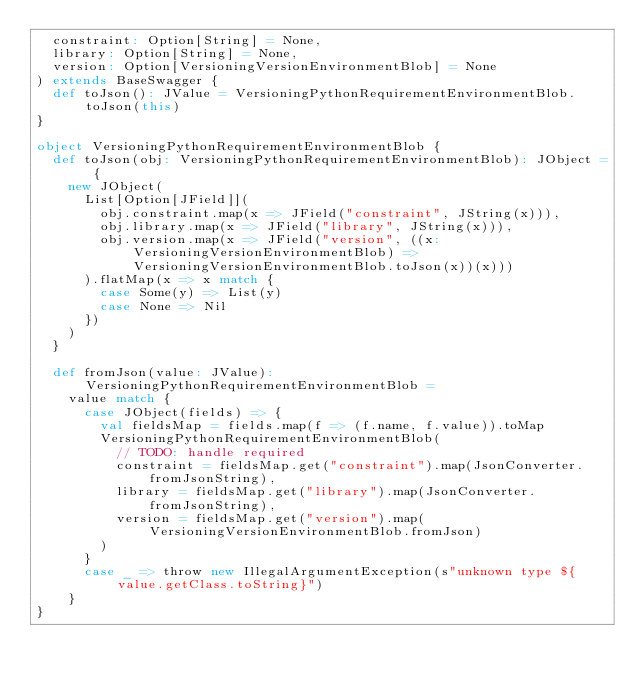<code> <loc_0><loc_0><loc_500><loc_500><_Scala_>  constraint: Option[String] = None,
  library: Option[String] = None,
  version: Option[VersioningVersionEnvironmentBlob] = None
) extends BaseSwagger {
  def toJson(): JValue = VersioningPythonRequirementEnvironmentBlob.toJson(this)
}

object VersioningPythonRequirementEnvironmentBlob {
  def toJson(obj: VersioningPythonRequirementEnvironmentBlob): JObject = {
    new JObject(
      List[Option[JField]](
        obj.constraint.map(x => JField("constraint", JString(x))),
        obj.library.map(x => JField("library", JString(x))),
        obj.version.map(x => JField("version", ((x: VersioningVersionEnvironmentBlob) => VersioningVersionEnvironmentBlob.toJson(x))(x)))
      ).flatMap(x => x match {
        case Some(y) => List(y)
        case None => Nil
      })
    )
  }

  def fromJson(value: JValue): VersioningPythonRequirementEnvironmentBlob =
    value match {
      case JObject(fields) => {
        val fieldsMap = fields.map(f => (f.name, f.value)).toMap
        VersioningPythonRequirementEnvironmentBlob(
          // TODO: handle required
          constraint = fieldsMap.get("constraint").map(JsonConverter.fromJsonString),
          library = fieldsMap.get("library").map(JsonConverter.fromJsonString),
          version = fieldsMap.get("version").map(VersioningVersionEnvironmentBlob.fromJson)
        )
      }
      case _ => throw new IllegalArgumentException(s"unknown type ${value.getClass.toString}")
    }
}
</code> 